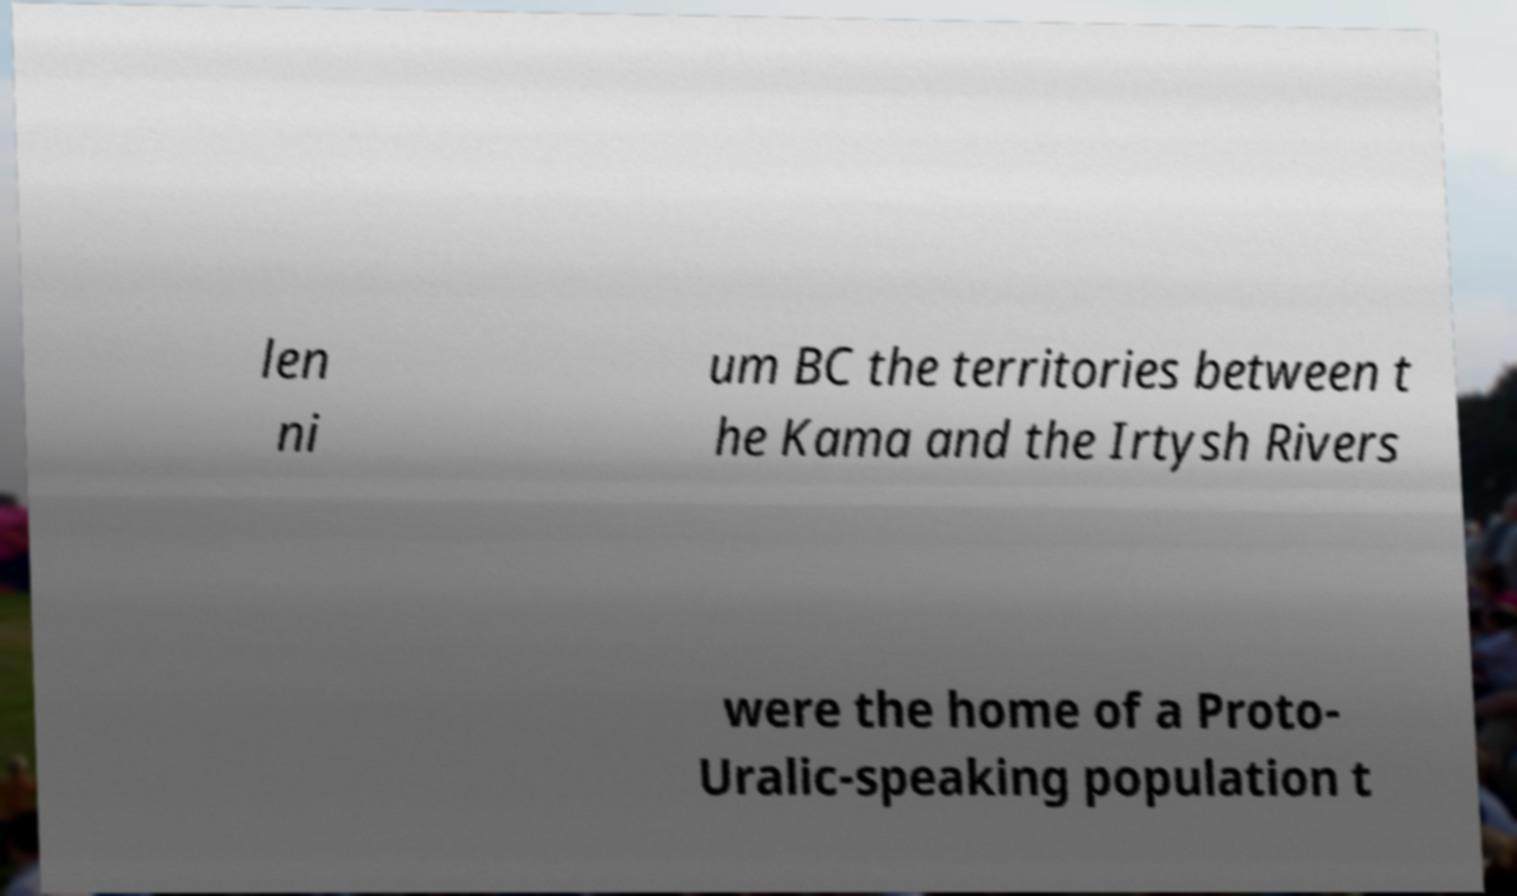For documentation purposes, I need the text within this image transcribed. Could you provide that? len ni um BC the territories between t he Kama and the Irtysh Rivers were the home of a Proto- Uralic-speaking population t 